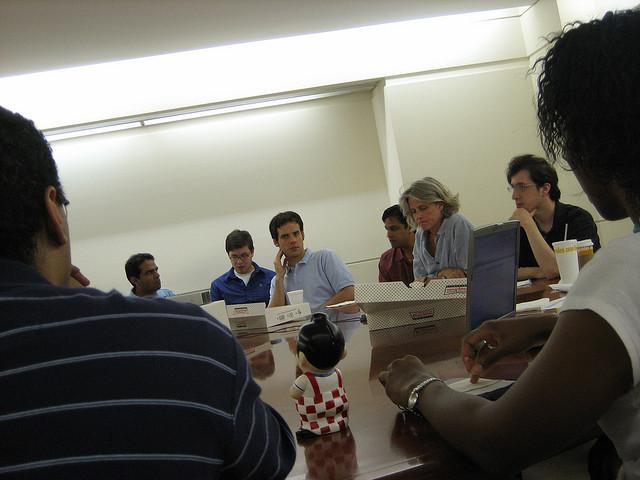How many people are wearing hats?
Give a very brief answer. 0. How many people are in the picture?
Give a very brief answer. 7. How many kites are there?
Give a very brief answer. 0. 